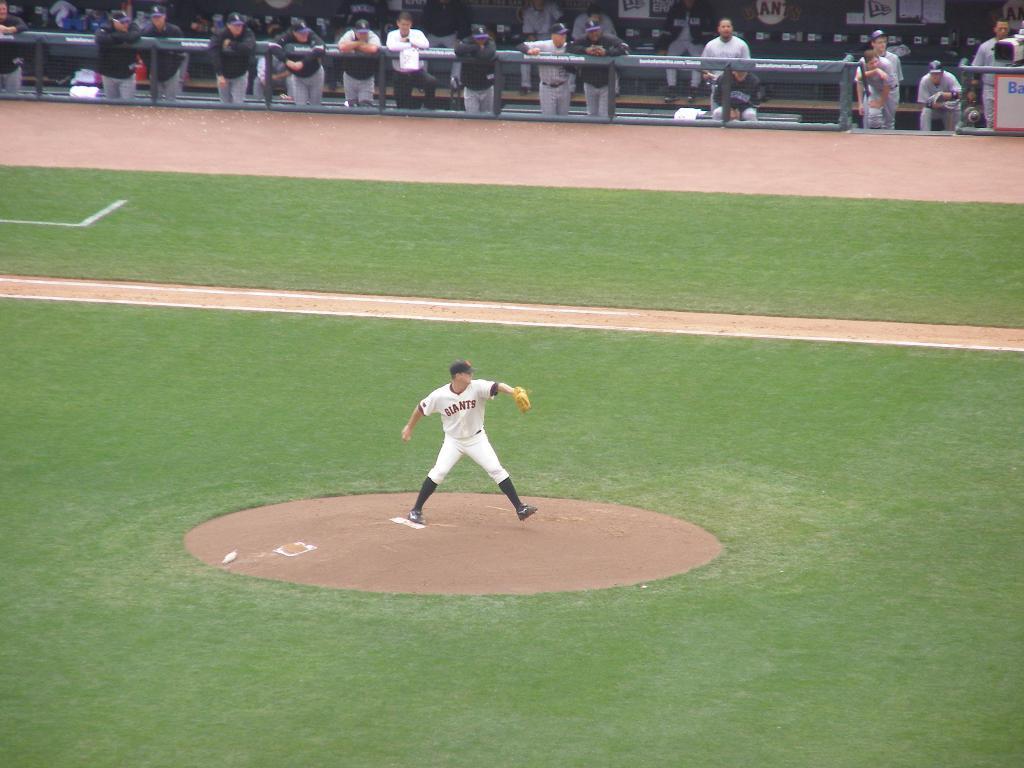Please provide a concise description of this image. In this image, we can see a person is standing on the ground and wearing gloves and cap. Here we can see grass and few white lines. Top of the image, we can see few people, rods. Few people are sitting and standing. Here there is a camera. 